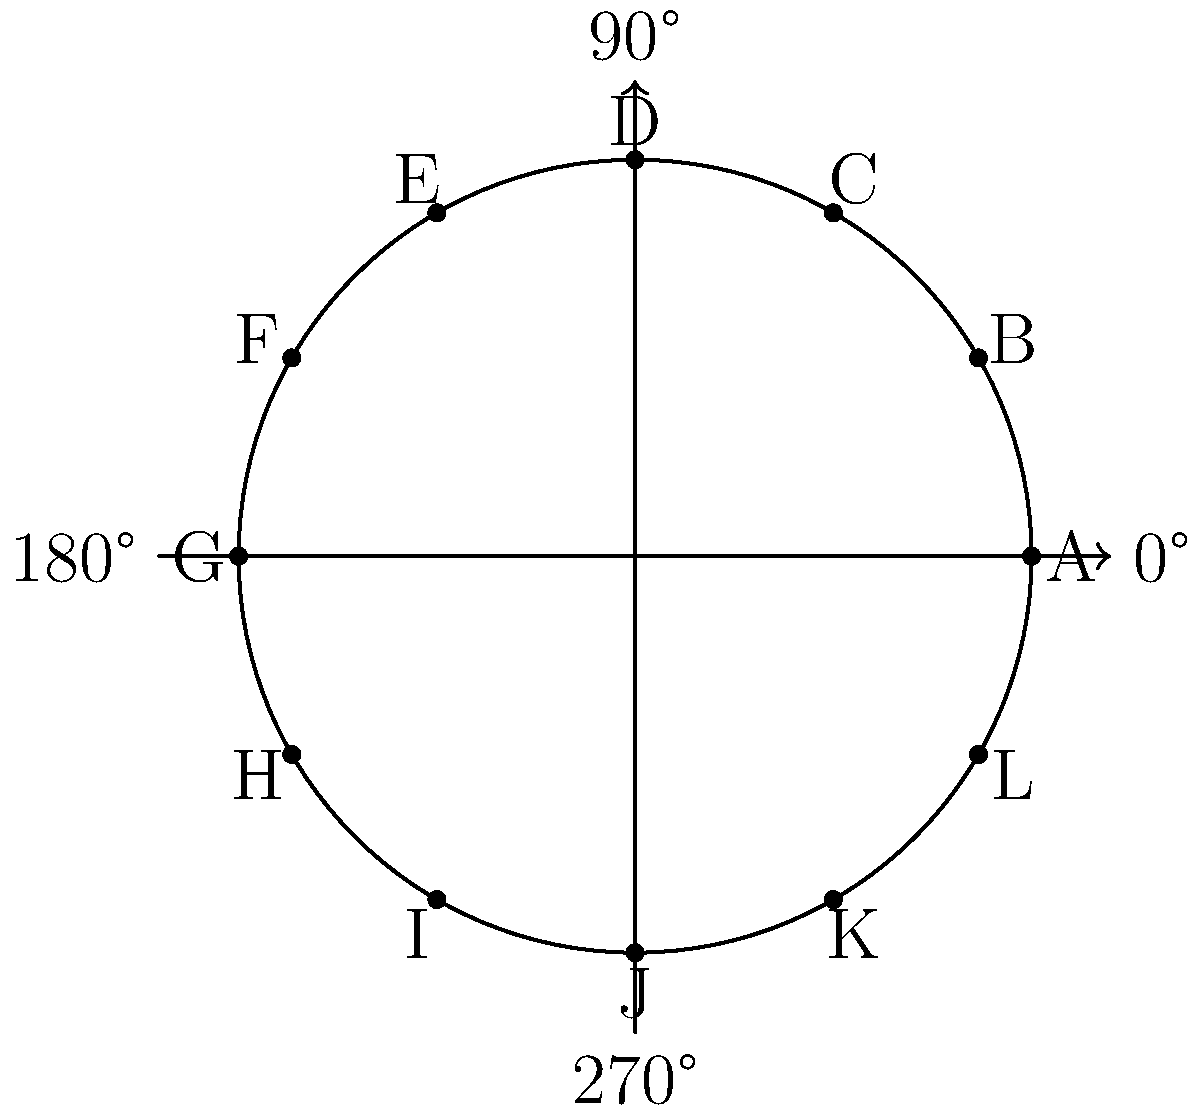In a Sherlock Holmes-themed escape room, you've encountered a mysterious cipher wheel. The wheel maps letters to angles in polar form, as shown in the diagram. To decode a secret message, you need to convert the following sequence of angles to letters: $$\left\{\frac{5\pi}{3}, \frac{\pi}{2}, \frac{4\pi}{3}, \frac{\pi}{3}, \frac{11\pi}{6}\right\}$$

What is the decoded message? To decode the message, we need to match each given angle with its corresponding letter on the cipher wheel. Let's go through the sequence step-by-step:

1. $\frac{5\pi}{3}$: This angle corresponds to the letter K on the wheel.
2. $\frac{\pi}{2}$: This angle (90°) corresponds to the letter D.
3. $\frac{4\pi}{3}$: This angle corresponds to the letter I.
4. $\frac{\pi}{3}$: This angle corresponds to the letter C.
5. $\frac{11\pi}{6}$: This angle corresponds to the letter L.

Putting these letters together in the order they appear in the sequence, we get the decoded message: KDICL.
Answer: KDICL 